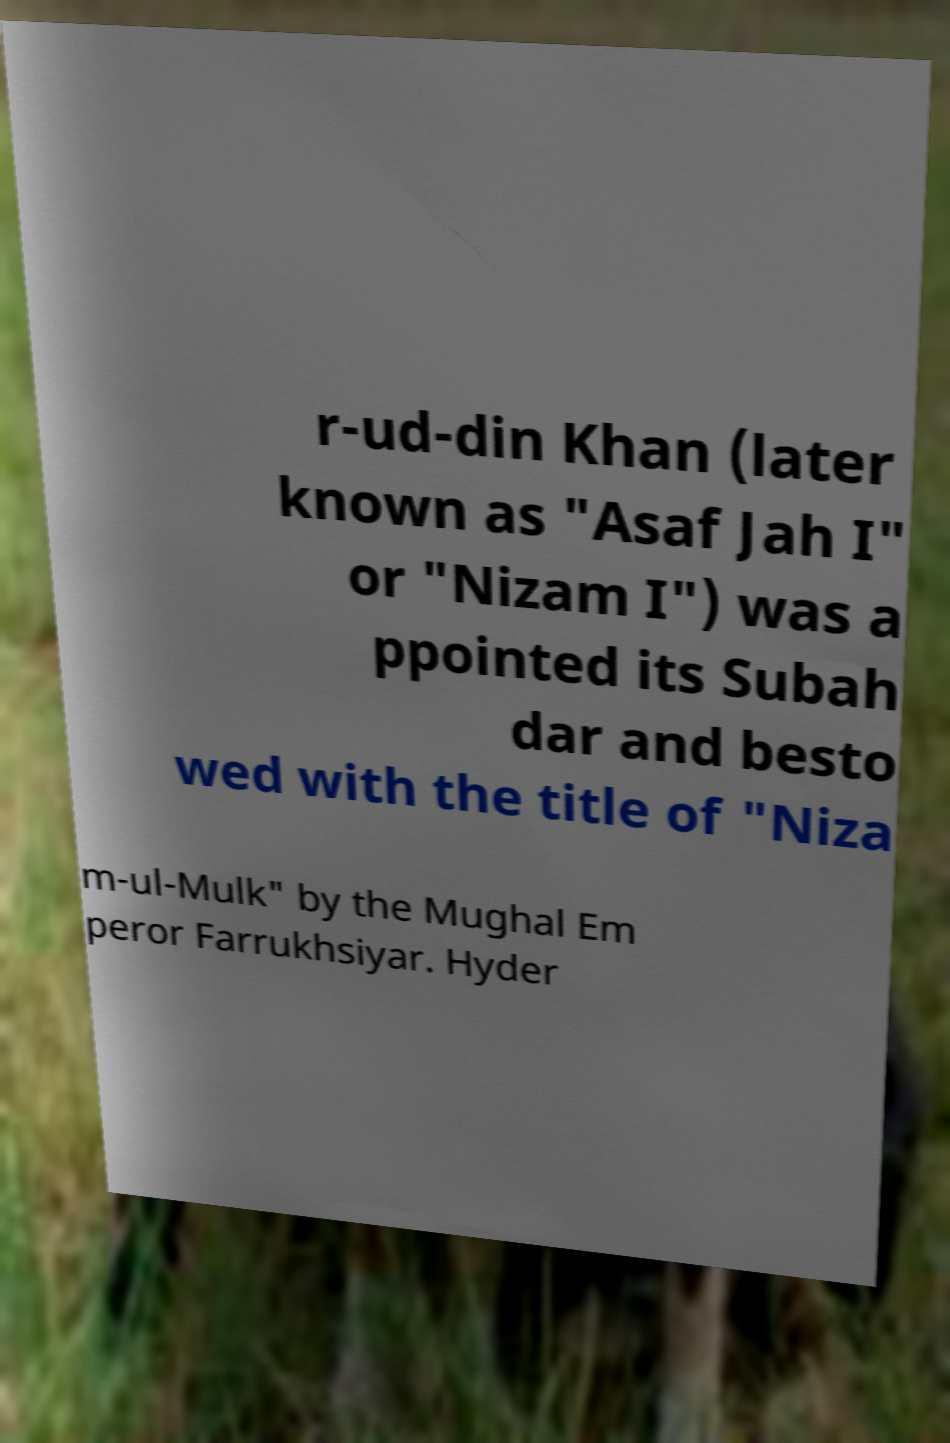Please read and relay the text visible in this image. What does it say? r-ud-din Khan (later known as "Asaf Jah I" or "Nizam I") was a ppointed its Subah dar and besto wed with the title of "Niza m-ul-Mulk" by the Mughal Em peror Farrukhsiyar. Hyder 